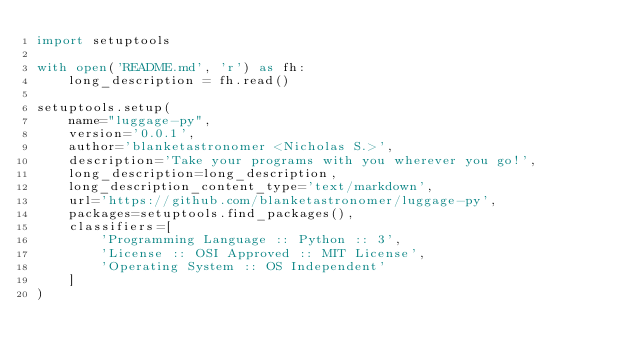<code> <loc_0><loc_0><loc_500><loc_500><_Python_>import setuptools

with open('README.md', 'r') as fh:
    long_description = fh.read()

setuptools.setup(
    name="luggage-py",
    version='0.0.1',
    author='blanketastronomer <Nicholas S.>',
    description='Take your programs with you wherever you go!',
    long_description=long_description,
    long_description_content_type='text/markdown',
    url='https://github.com/blanketastronomer/luggage-py',
    packages=setuptools.find_packages(),
    classifiers=[
        'Programming Language :: Python :: 3',
        'License :: OSI Approved :: MIT License',
        'Operating System :: OS Independent'
    ]
)</code> 